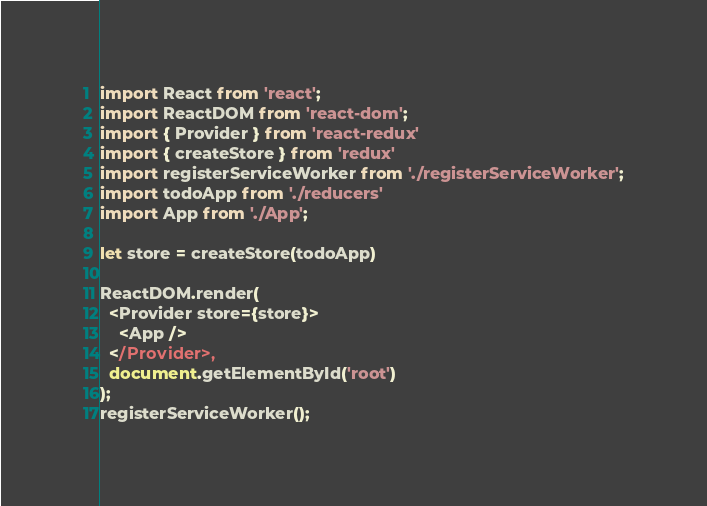<code> <loc_0><loc_0><loc_500><loc_500><_JavaScript_>import React from 'react';
import ReactDOM from 'react-dom';
import { Provider } from 'react-redux'
import { createStore } from 'redux'
import registerServiceWorker from './registerServiceWorker';
import todoApp from './reducers'
import App from './App';

let store = createStore(todoApp)

ReactDOM.render(
  <Provider store={store}>
    <App />
  </Provider>,
  document.getElementById('root')
);
registerServiceWorker();</code> 